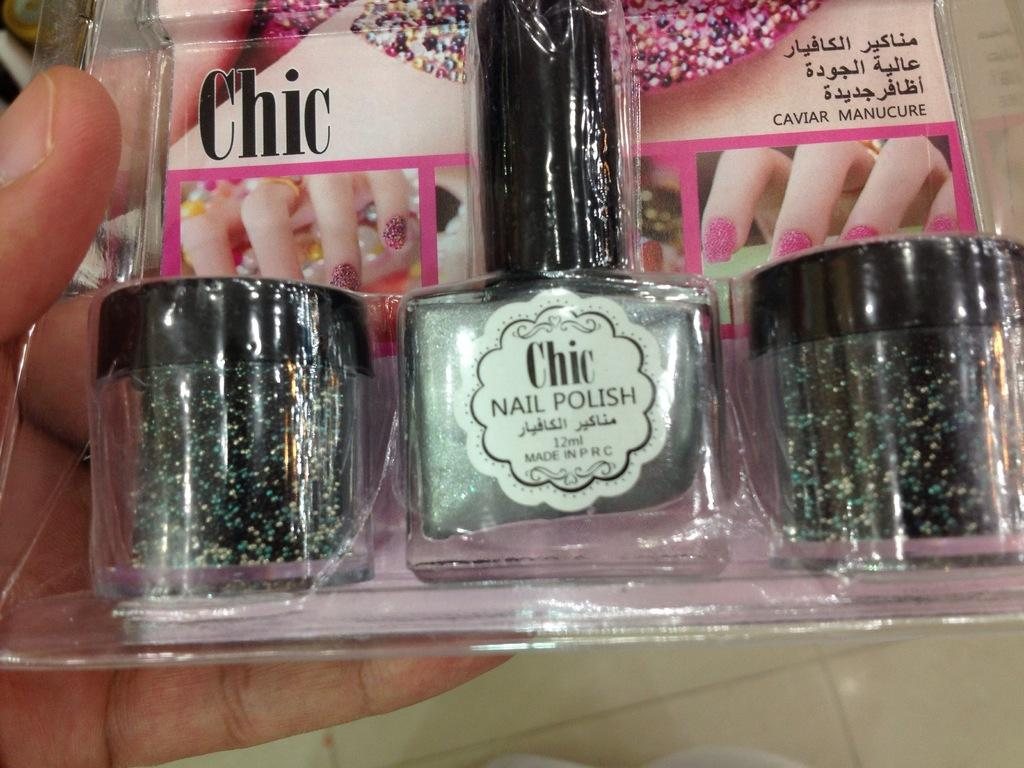<image>
Write a terse but informative summary of the picture. A person is holding a package of Chic silver nail polish with glitter in it. 